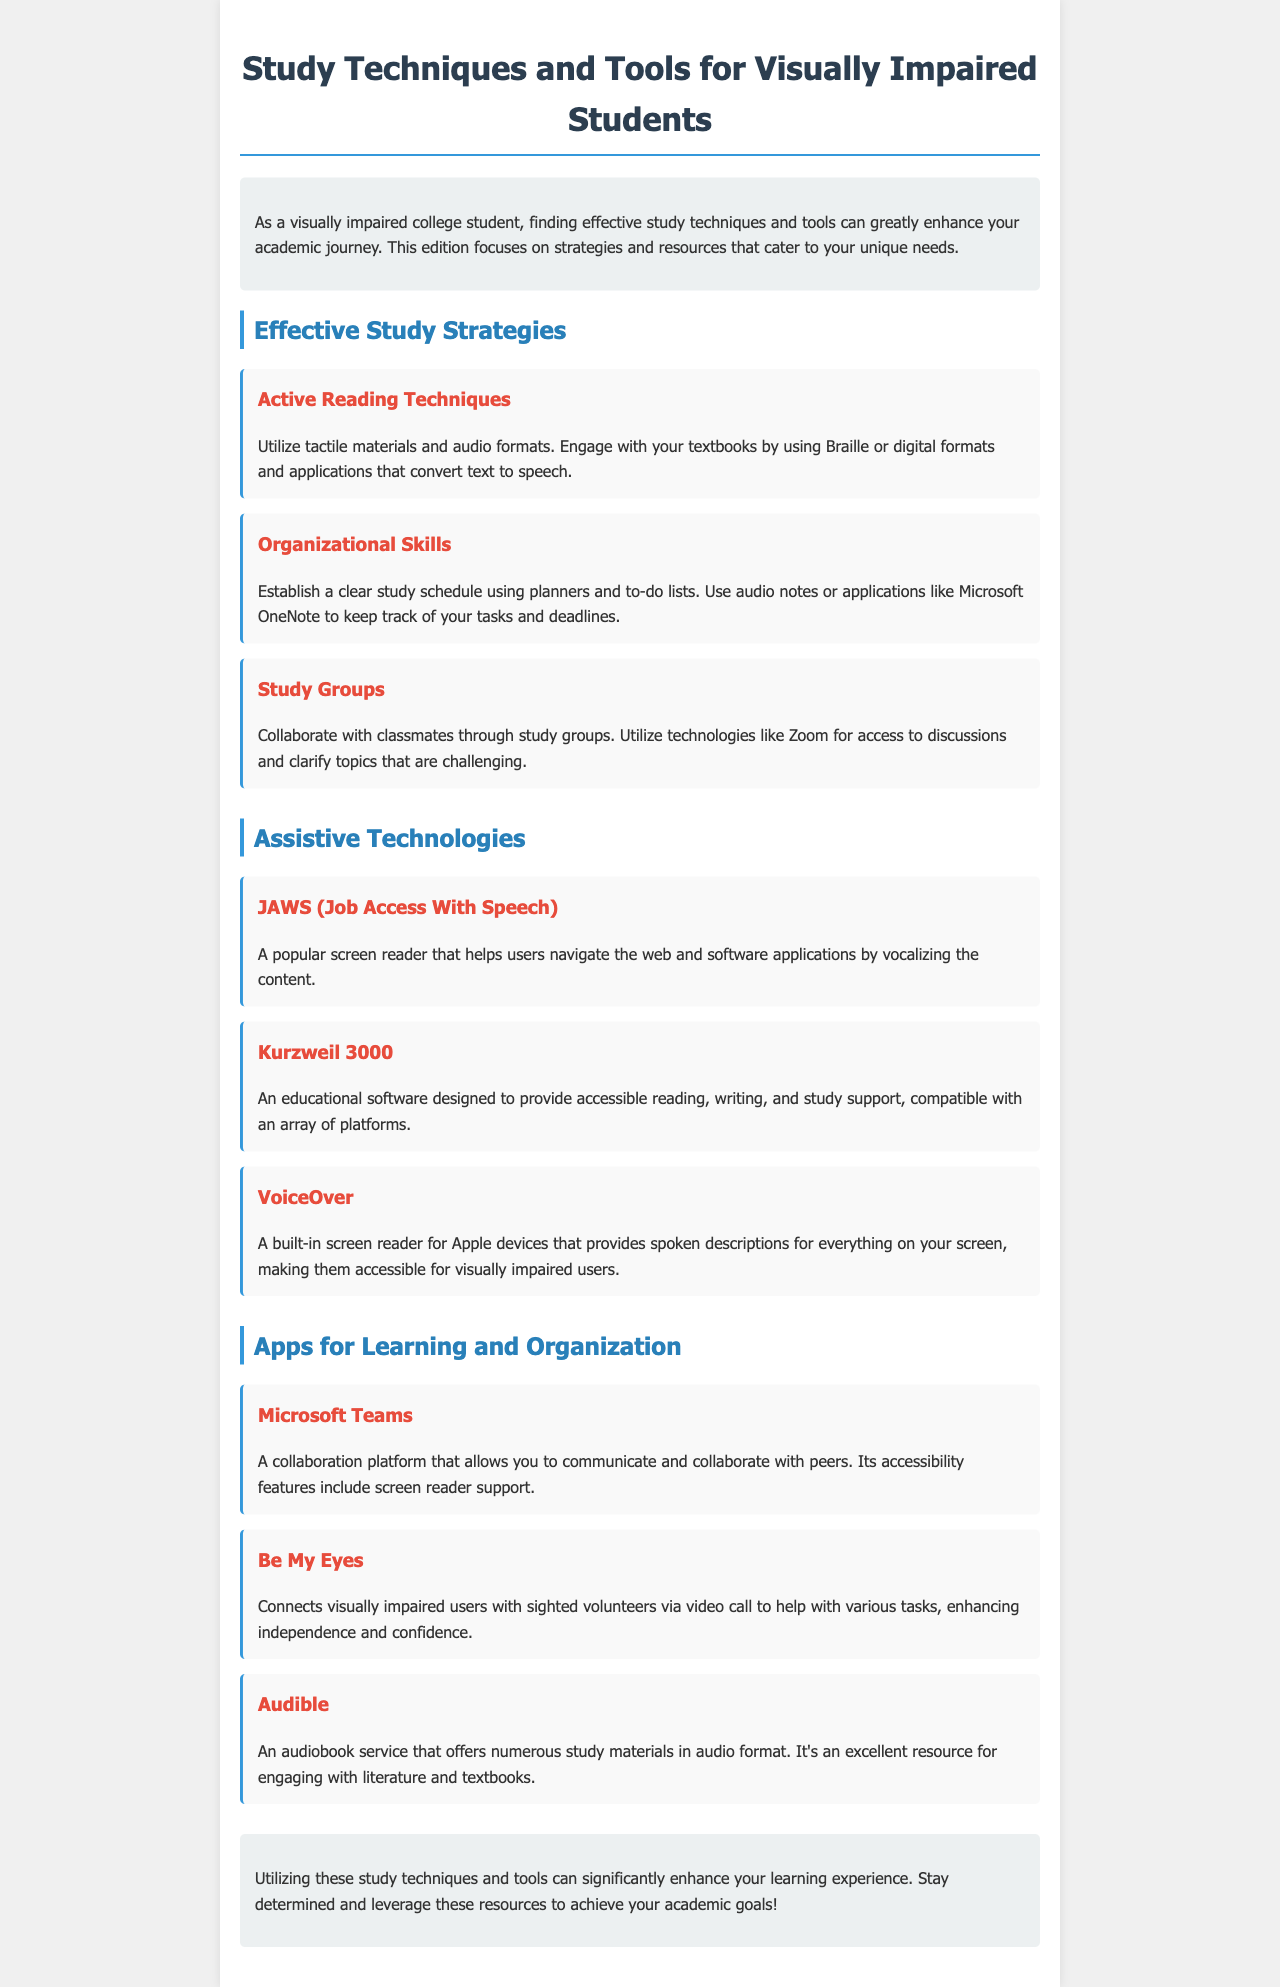What is the main purpose of this newsletter? The main purpose of the newsletter is to provide effective study techniques and tools for visually impaired students to enhance their academic journey.
Answer: Enhancing academic journey What is an example of an active reading technique? An example of an active reading technique mentioned is using tactile materials and audio formats.
Answer: Tactile materials and audio formats Which app is mentioned for organizing study tasks? The app mentioned for organizing study tasks is Microsoft OneNote.
Answer: Microsoft OneNote What technology is described as a popular screen reader? The technology described as a popular screen reader is JAWS.
Answer: JAWS How does the 'Be My Eyes' app assist users? The 'Be My Eyes' app connects visually impaired users with sighted volunteers to help with various tasks.
Answer: Connecting with sighted volunteers What is the conclusion of the newsletter? The conclusion suggests using study techniques and tools to enhance the learning experience and achieve academic goals.
Answer: Enhance learning experience How many sections are in the newsletter? There are three main sections in the newsletter: Effective Study Strategies, Assistive Technologies, and Apps for Learning and Organization.
Answer: Three What color is used for the main title of the newsletter? The color used for the main title of the newsletter is #2c3e50.
Answer: #2c3e50 What platform is mentioned for collaboration with peers? The platform mentioned for collaboration with peers is Microsoft Teams.
Answer: Microsoft Teams 